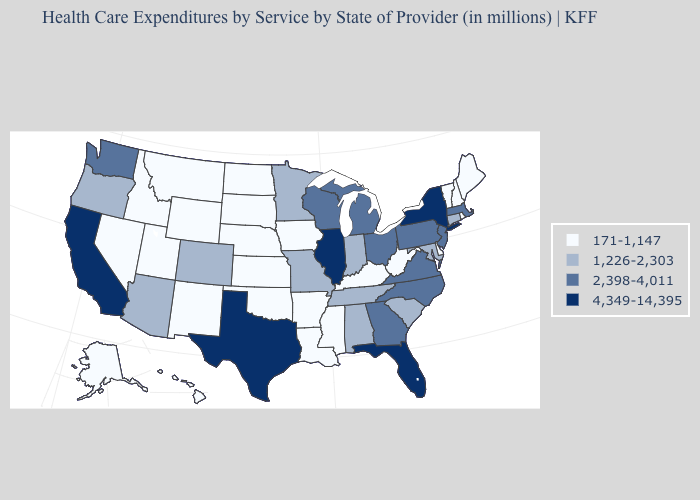Name the states that have a value in the range 171-1,147?
Answer briefly. Alaska, Arkansas, Delaware, Hawaii, Idaho, Iowa, Kansas, Kentucky, Louisiana, Maine, Mississippi, Montana, Nebraska, Nevada, New Hampshire, New Mexico, North Dakota, Oklahoma, Rhode Island, South Dakota, Utah, Vermont, West Virginia, Wyoming. Which states have the lowest value in the Northeast?
Be succinct. Maine, New Hampshire, Rhode Island, Vermont. Name the states that have a value in the range 4,349-14,395?
Concise answer only. California, Florida, Illinois, New York, Texas. Name the states that have a value in the range 171-1,147?
Short answer required. Alaska, Arkansas, Delaware, Hawaii, Idaho, Iowa, Kansas, Kentucky, Louisiana, Maine, Mississippi, Montana, Nebraska, Nevada, New Hampshire, New Mexico, North Dakota, Oklahoma, Rhode Island, South Dakota, Utah, Vermont, West Virginia, Wyoming. What is the value of Oregon?
Give a very brief answer. 1,226-2,303. Name the states that have a value in the range 4,349-14,395?
Write a very short answer. California, Florida, Illinois, New York, Texas. How many symbols are there in the legend?
Keep it brief. 4. What is the lowest value in the USA?
Write a very short answer. 171-1,147. Among the states that border South Carolina , which have the lowest value?
Give a very brief answer. Georgia, North Carolina. Among the states that border Alabama , which have the highest value?
Keep it brief. Florida. Among the states that border New York , which have the lowest value?
Short answer required. Vermont. Which states have the lowest value in the South?
Quick response, please. Arkansas, Delaware, Kentucky, Louisiana, Mississippi, Oklahoma, West Virginia. Does South Dakota have a lower value than Connecticut?
Write a very short answer. Yes. Which states hav the highest value in the MidWest?
Keep it brief. Illinois. Does New York have the highest value in the Northeast?
Keep it brief. Yes. 